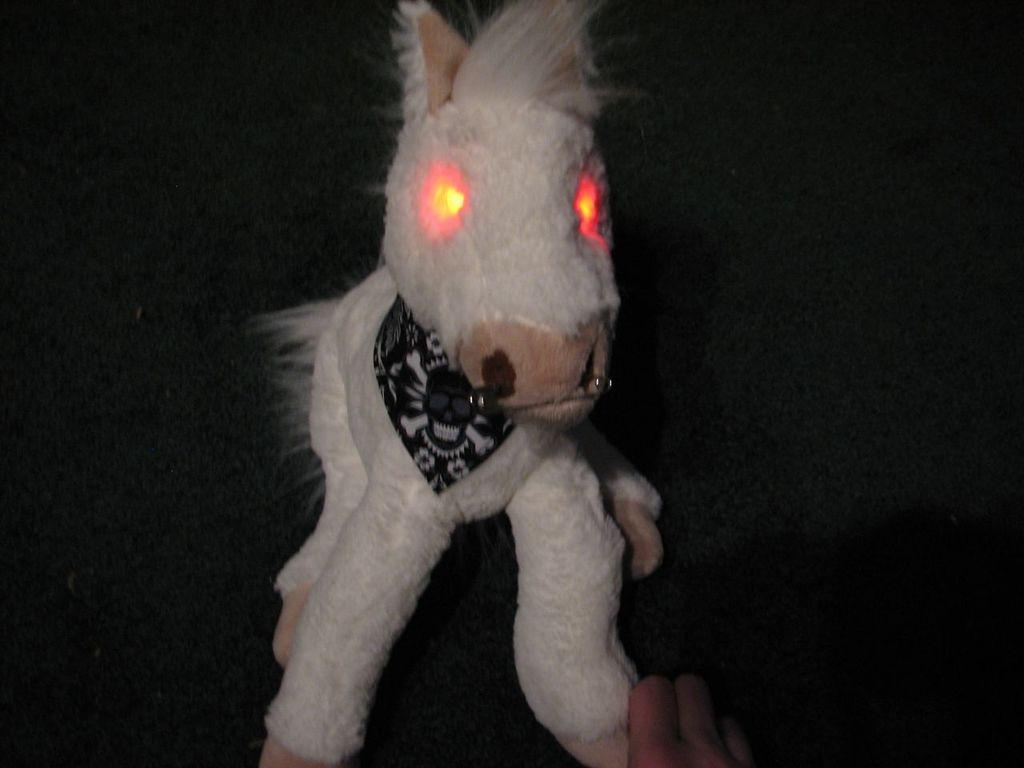What object can be seen in the image? There is a toy in the image. What can be observed about the background of the image? The background of the image is dark. What type of dirt can be seen on the toy in the image? There is no dirt visible on the toy in the image. What route is the toy taking in the image? The toy is not taking any route in the image; it is stationary. 